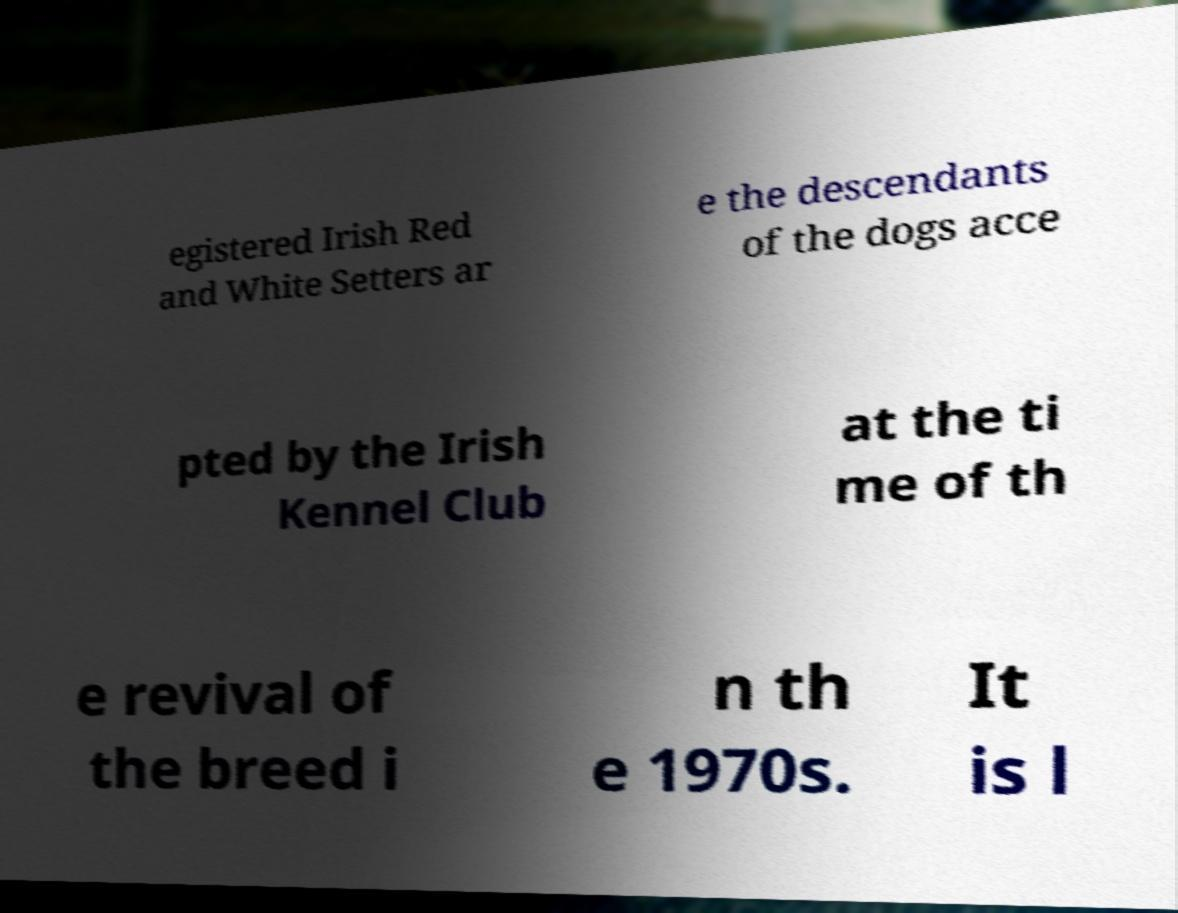For documentation purposes, I need the text within this image transcribed. Could you provide that? egistered Irish Red and White Setters ar e the descendants of the dogs acce pted by the Irish Kennel Club at the ti me of th e revival of the breed i n th e 1970s. It is l 